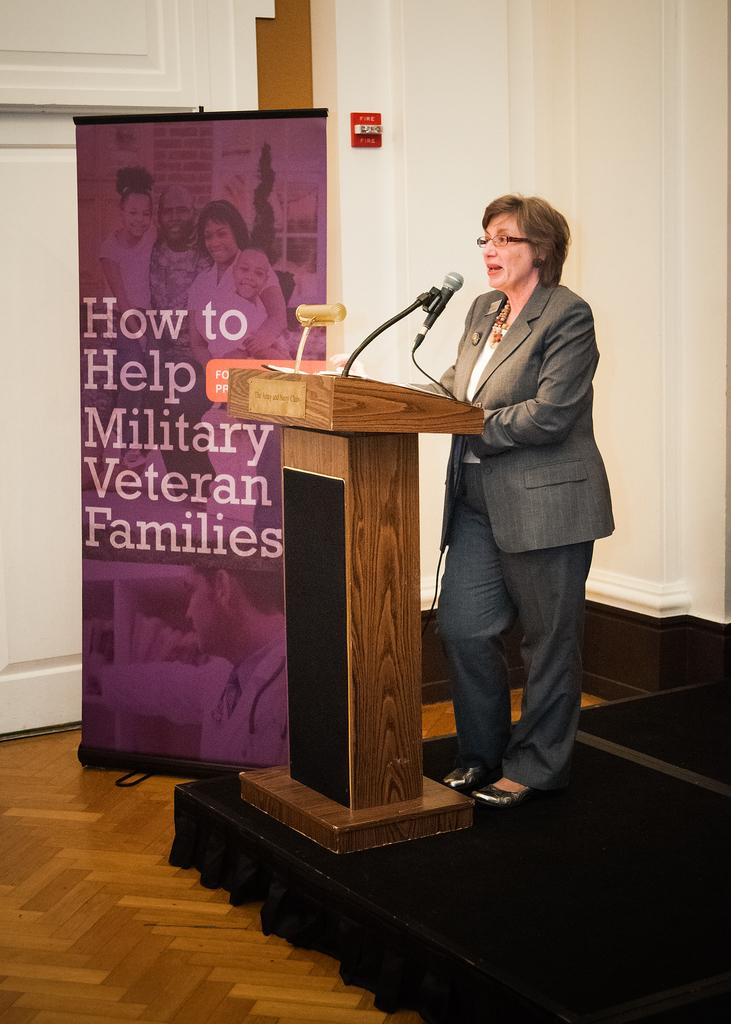What is the woman doing in the image? The woman is standing on a stage. What is in front of the woman on the stage? There is a podium in front of the woman. What is on the podium? There are mice on the podium. What can be seen in the background of the image? There is a poster with text on it in the background. What is the price of the underwear being sold on the stage? There is no underwear being sold on the stage in the image, and therefore no price can be determined. What type of brush is being used by the woman on the stage? There is no brush visible in the image, and the woman is not using any tool or object on the stage. 